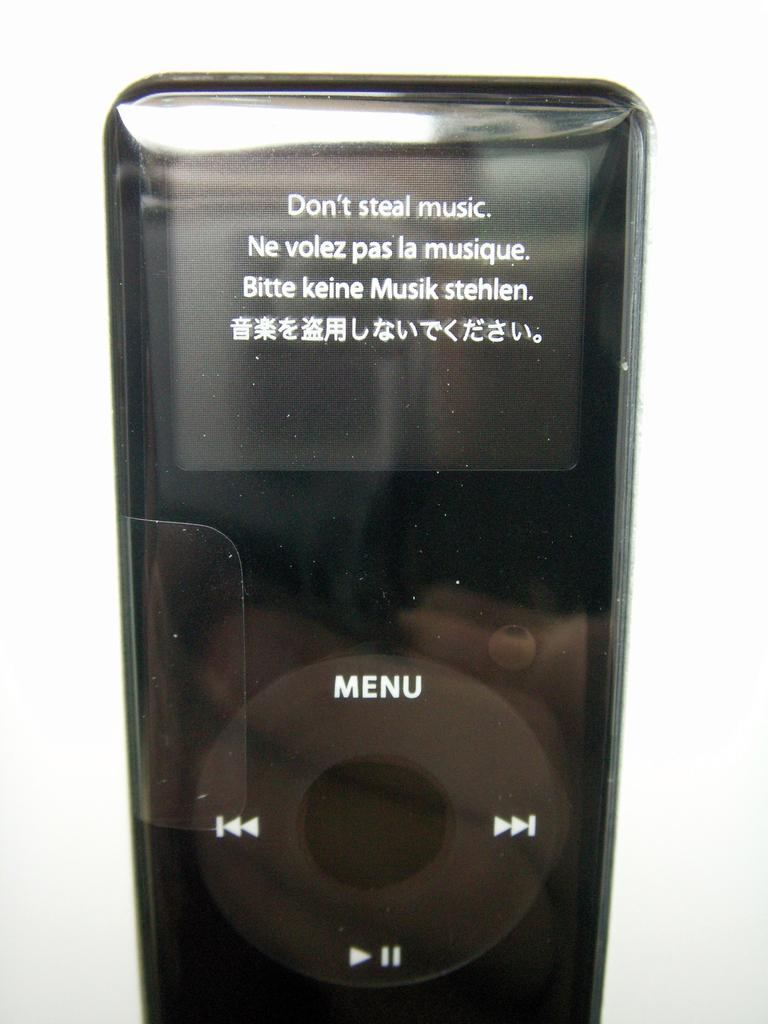<image>
Describe the image concisely. An Ipod that states Don't steal music in multiple languages. 